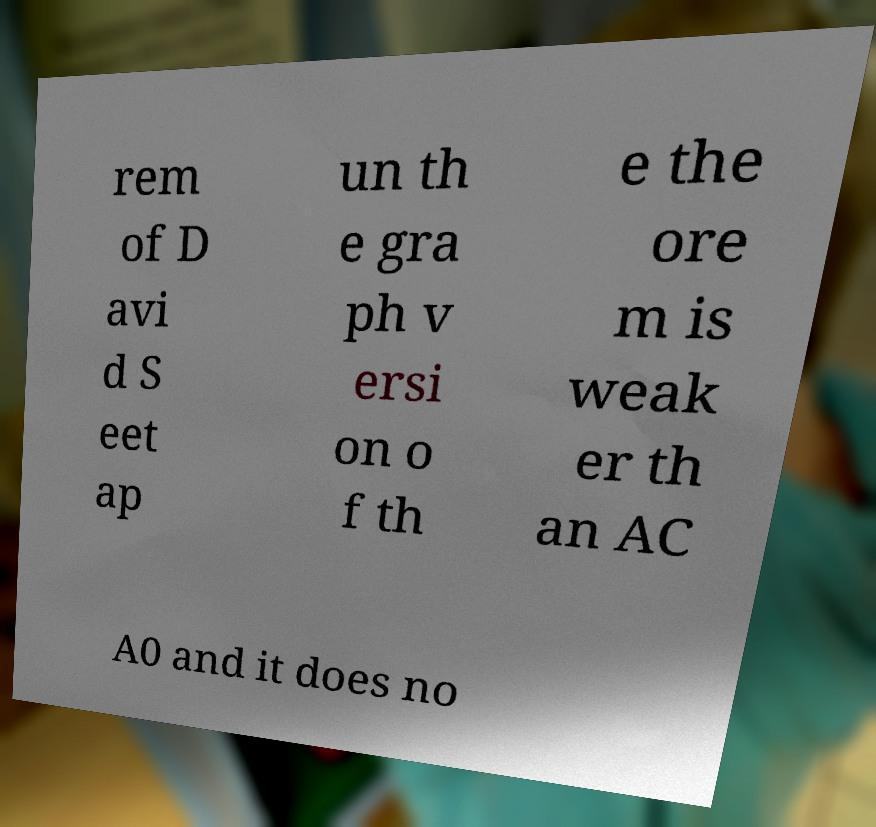Please read and relay the text visible in this image. What does it say? rem of D avi d S eet ap un th e gra ph v ersi on o f th e the ore m is weak er th an AC A0 and it does no 